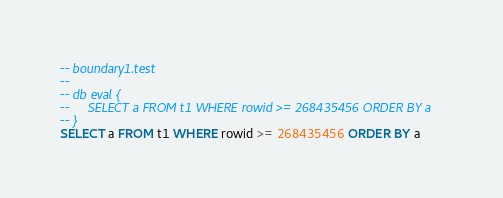<code> <loc_0><loc_0><loc_500><loc_500><_SQL_>-- boundary1.test
-- 
-- db eval {
--     SELECT a FROM t1 WHERE rowid >= 268435456 ORDER BY a
-- }
SELECT a FROM t1 WHERE rowid >= 268435456 ORDER BY a</code> 